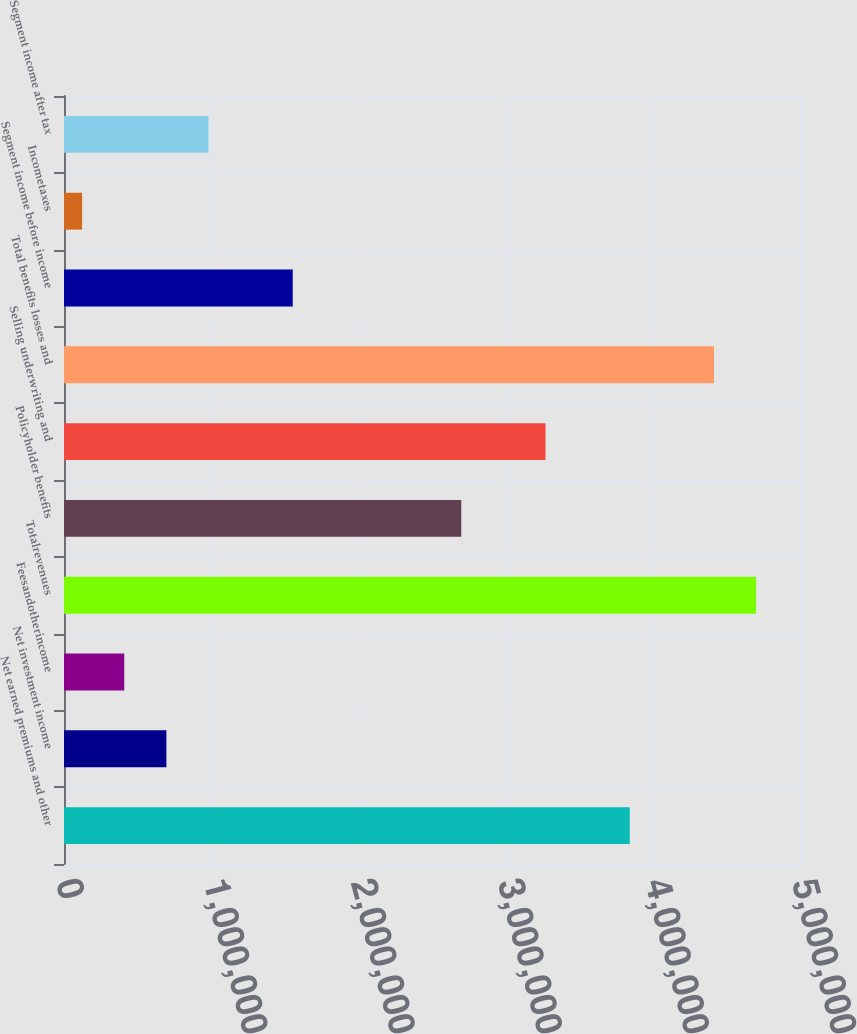<chart> <loc_0><loc_0><loc_500><loc_500><bar_chart><fcel>Net earned premiums and other<fcel>Net investment income<fcel>Feesandotherincome<fcel>Totalrevenues<fcel>Policyholder benefits<fcel>Selling underwriting and<fcel>Total benefits losses and<fcel>Segment income before income<fcel>Incometaxes<fcel>Segment income after tax<nl><fcel>3.84354e+06<fcel>695457<fcel>409268<fcel>4.70211e+06<fcel>2.69878e+06<fcel>3.27116e+06<fcel>4.41592e+06<fcel>1.55403e+06<fcel>123078<fcel>981646<nl></chart> 